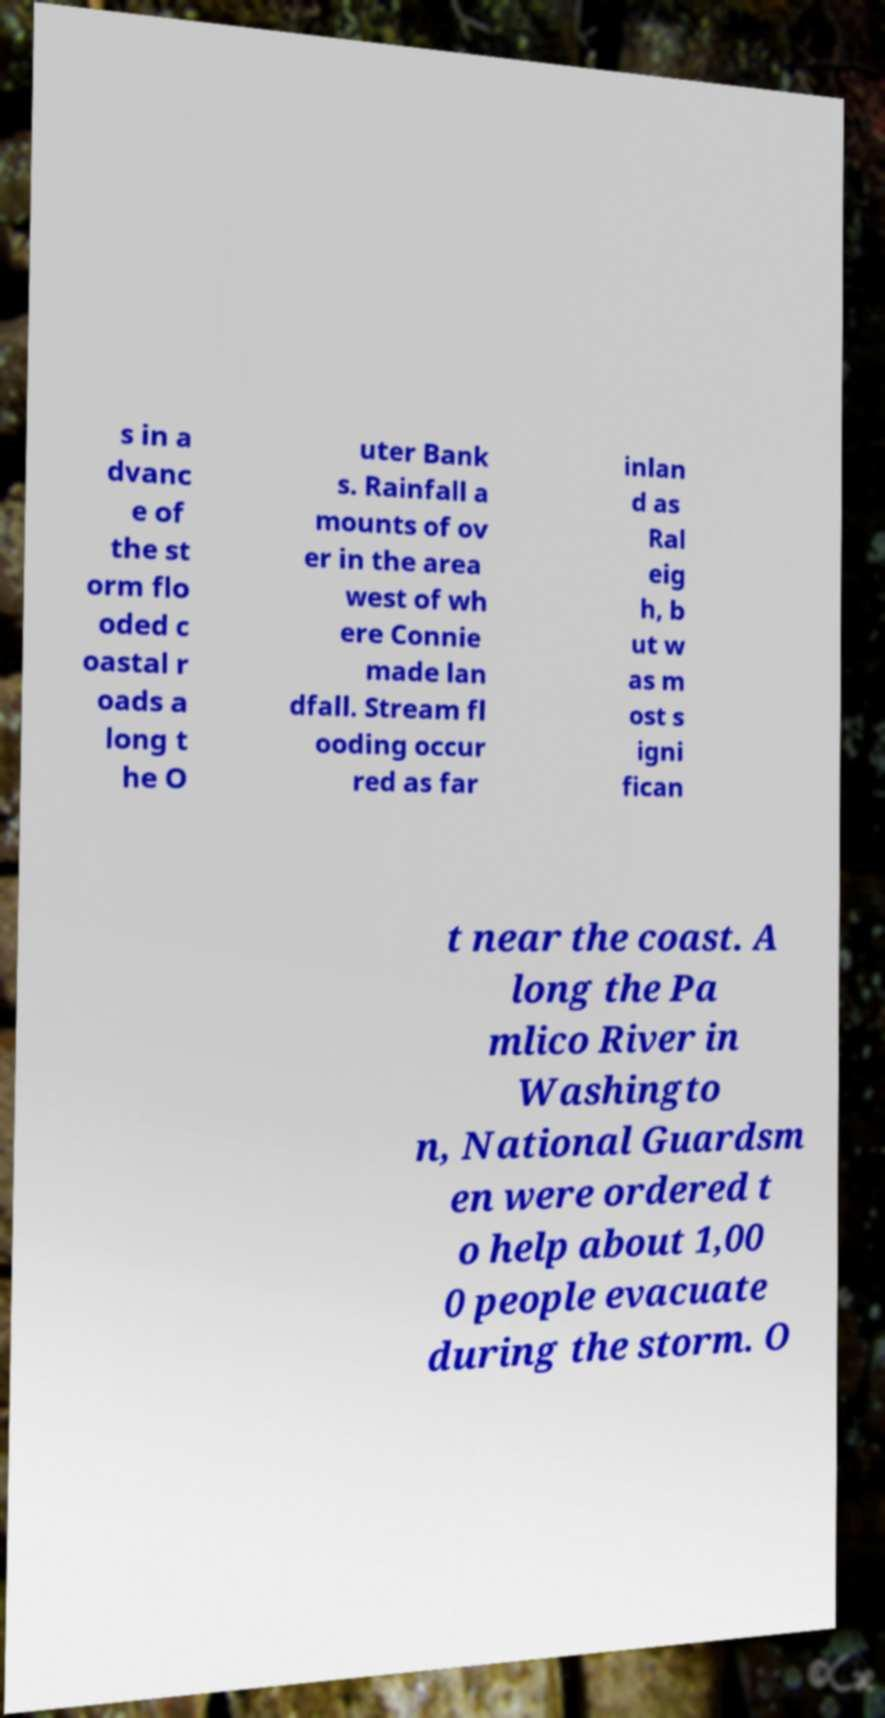I need the written content from this picture converted into text. Can you do that? s in a dvanc e of the st orm flo oded c oastal r oads a long t he O uter Bank s. Rainfall a mounts of ov er in the area west of wh ere Connie made lan dfall. Stream fl ooding occur red as far inlan d as Ral eig h, b ut w as m ost s igni fican t near the coast. A long the Pa mlico River in Washingto n, National Guardsm en were ordered t o help about 1,00 0 people evacuate during the storm. O 